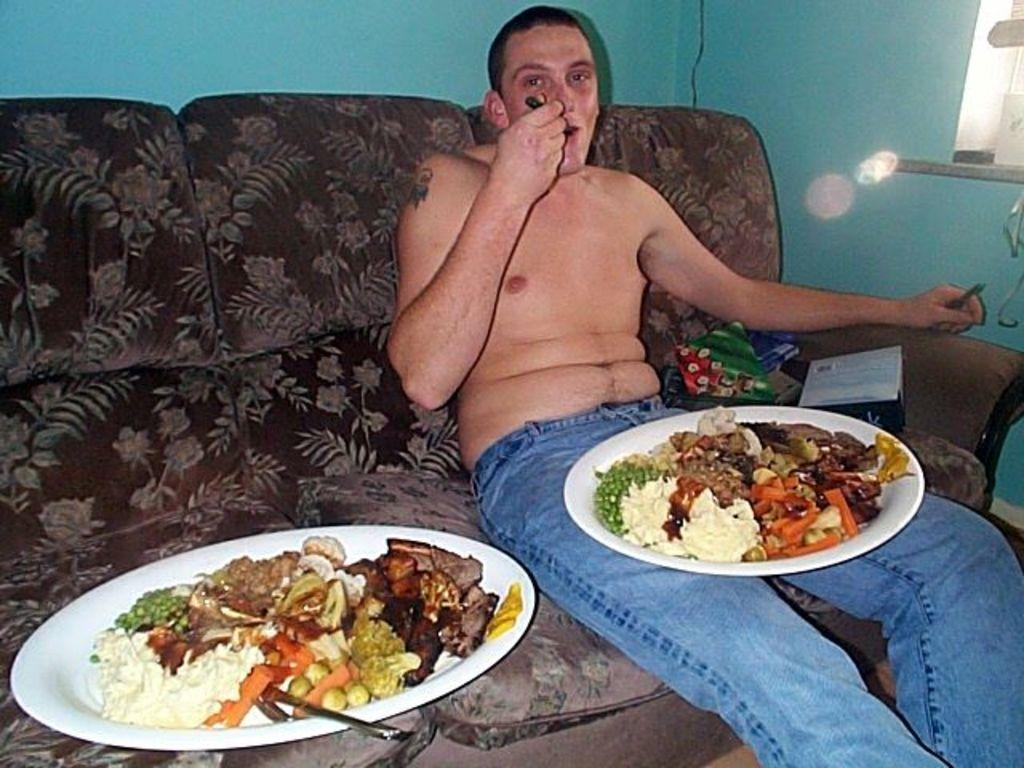Who is present in the image? There is a man in the image. What is the man doing in the image? The man is sitting on a sofa. What is on the man's lap and on the sofa? There are plates on the man's lap and on the sofa. What is on the plates? The plates contain food items. What can be seen in the background of the image? There is a wall in the background of the image. What type of doctor is attending to the man in the image? There is no doctor present in the image; it only shows a man sitting on a sofa with plates containing food items. 